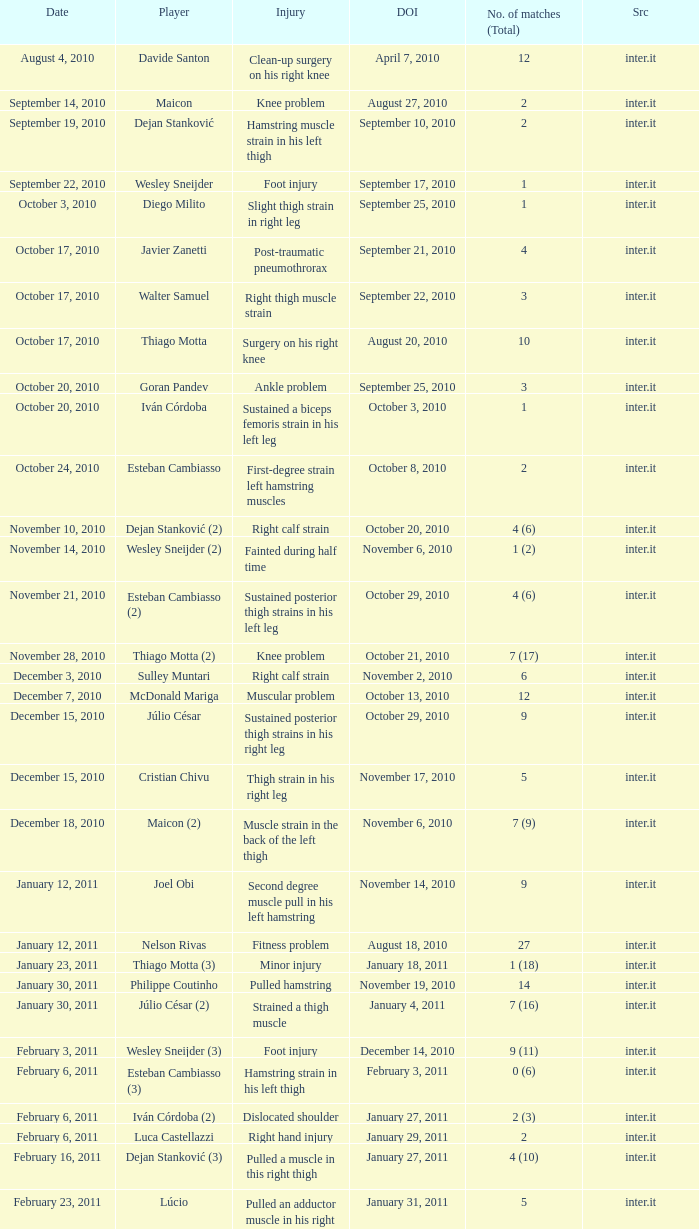What is the date of injury for player Wesley sneijder (2)? November 6, 2010. 